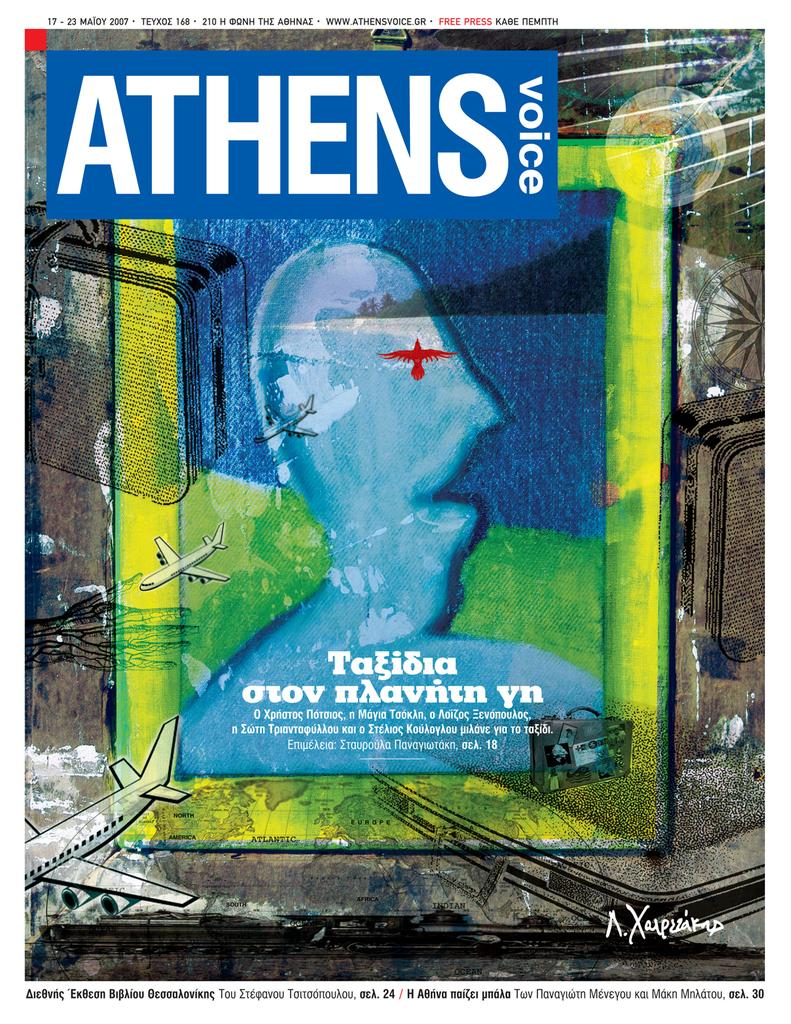<image>
Render a clear and concise summary of the photo. A poster for ATHENS voice with an artistic depiction of a person's face in profile. 